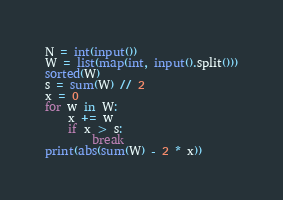Convert code to text. <code><loc_0><loc_0><loc_500><loc_500><_Python_>N = int(input())
W = list(map(int, input().split()))
sorted(W)
s = sum(W) // 2
x = 0
for w in W:
    x += w
    if x > s:
        break
print(abs(sum(W) - 2 * x))</code> 